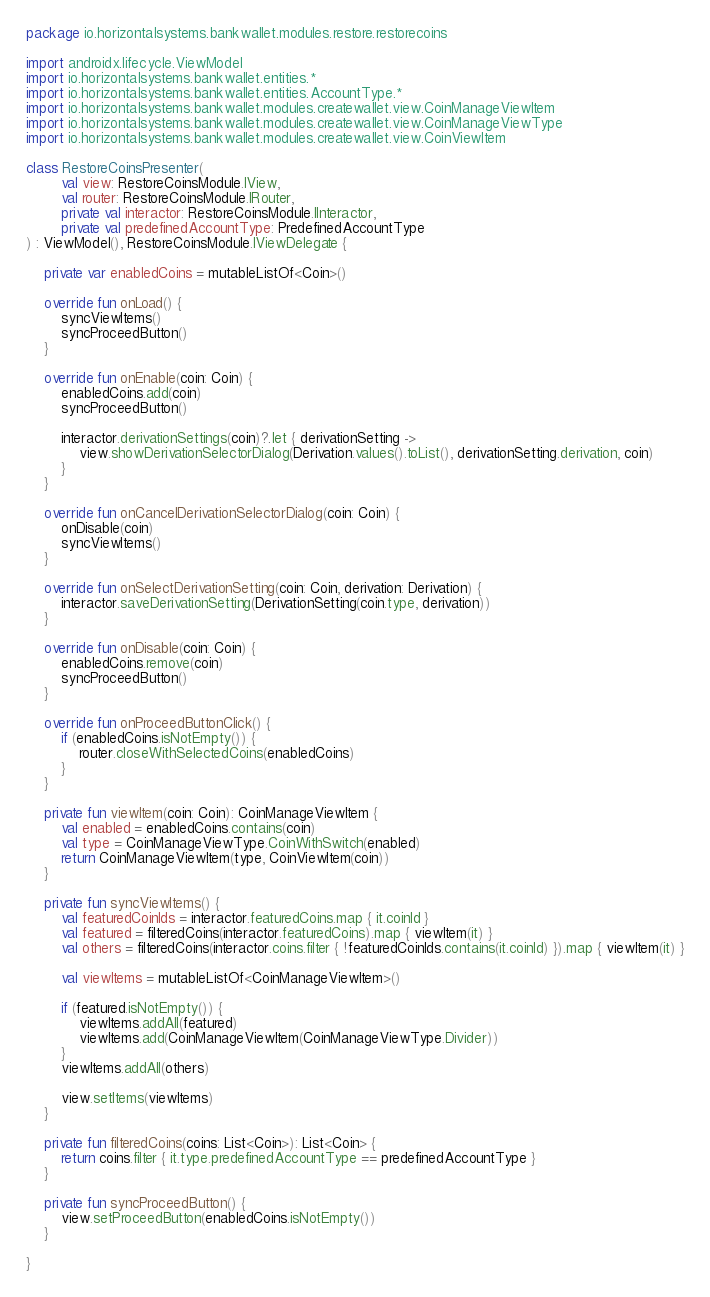<code> <loc_0><loc_0><loc_500><loc_500><_Kotlin_>package io.horizontalsystems.bankwallet.modules.restore.restorecoins

import androidx.lifecycle.ViewModel
import io.horizontalsystems.bankwallet.entities.*
import io.horizontalsystems.bankwallet.entities.AccountType.*
import io.horizontalsystems.bankwallet.modules.createwallet.view.CoinManageViewItem
import io.horizontalsystems.bankwallet.modules.createwallet.view.CoinManageViewType
import io.horizontalsystems.bankwallet.modules.createwallet.view.CoinViewItem

class RestoreCoinsPresenter(
        val view: RestoreCoinsModule.IView,
        val router: RestoreCoinsModule.IRouter,
        private val interactor: RestoreCoinsModule.IInteractor,
        private val predefinedAccountType: PredefinedAccountType
) : ViewModel(), RestoreCoinsModule.IViewDelegate {

    private var enabledCoins = mutableListOf<Coin>()

    override fun onLoad() {
        syncViewItems()
        syncProceedButton()
    }

    override fun onEnable(coin: Coin) {
        enabledCoins.add(coin)
        syncProceedButton()

        interactor.derivationSettings(coin)?.let { derivationSetting ->
            view.showDerivationSelectorDialog(Derivation.values().toList(), derivationSetting.derivation, coin)
        }
    }

    override fun onCancelDerivationSelectorDialog(coin: Coin) {
        onDisable(coin)
        syncViewItems()
    }

    override fun onSelectDerivationSetting(coin: Coin, derivation: Derivation) {
        interactor.saveDerivationSetting(DerivationSetting(coin.type, derivation))
    }

    override fun onDisable(coin: Coin) {
        enabledCoins.remove(coin)
        syncProceedButton()
    }

    override fun onProceedButtonClick() {
        if (enabledCoins.isNotEmpty()) {
            router.closeWithSelectedCoins(enabledCoins)
        }
    }

    private fun viewItem(coin: Coin): CoinManageViewItem {
        val enabled = enabledCoins.contains(coin)
        val type = CoinManageViewType.CoinWithSwitch(enabled)
        return CoinManageViewItem(type, CoinViewItem(coin))
    }

    private fun syncViewItems() {
        val featuredCoinIds = interactor.featuredCoins.map { it.coinId }
        val featured = filteredCoins(interactor.featuredCoins).map { viewItem(it) }
        val others = filteredCoins(interactor.coins.filter { !featuredCoinIds.contains(it.coinId) }).map { viewItem(it) }

        val viewItems = mutableListOf<CoinManageViewItem>()

        if (featured.isNotEmpty()) {
            viewItems.addAll(featured)
            viewItems.add(CoinManageViewItem(CoinManageViewType.Divider))
        }
        viewItems.addAll(others)

        view.setItems(viewItems)
    }

    private fun filteredCoins(coins: List<Coin>): List<Coin> {
        return coins.filter { it.type.predefinedAccountType == predefinedAccountType }
    }

    private fun syncProceedButton() {
        view.setProceedButton(enabledCoins.isNotEmpty())
    }

}
</code> 